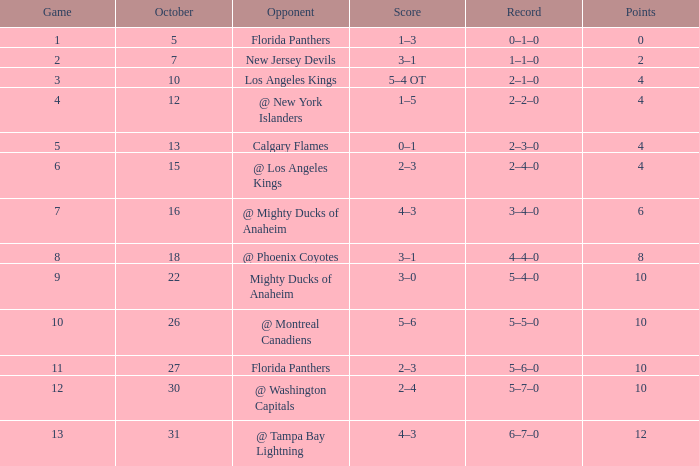What team has a score of 2 3–1. 